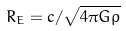<formula> <loc_0><loc_0><loc_500><loc_500>R _ { E } = c / \sqrt { 4 \pi G \rho }</formula> 